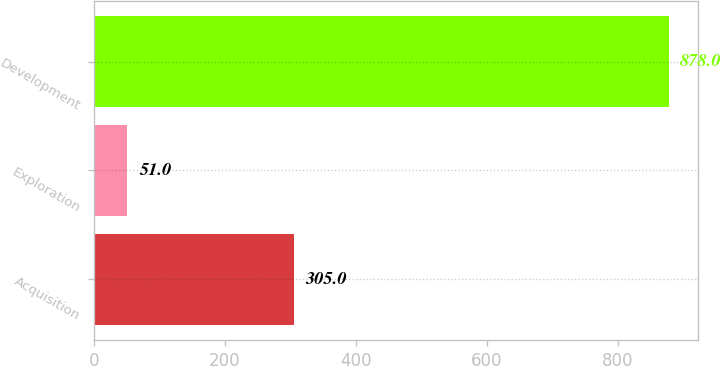Convert chart. <chart><loc_0><loc_0><loc_500><loc_500><bar_chart><fcel>Acquisition<fcel>Exploration<fcel>Development<nl><fcel>305<fcel>51<fcel>878<nl></chart> 